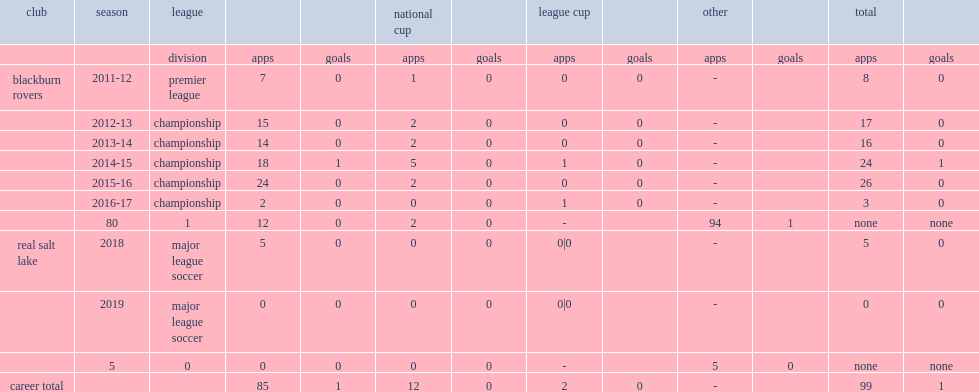In 2018, which club did adam henley sign with the major league soccer club? Real salt lake. 